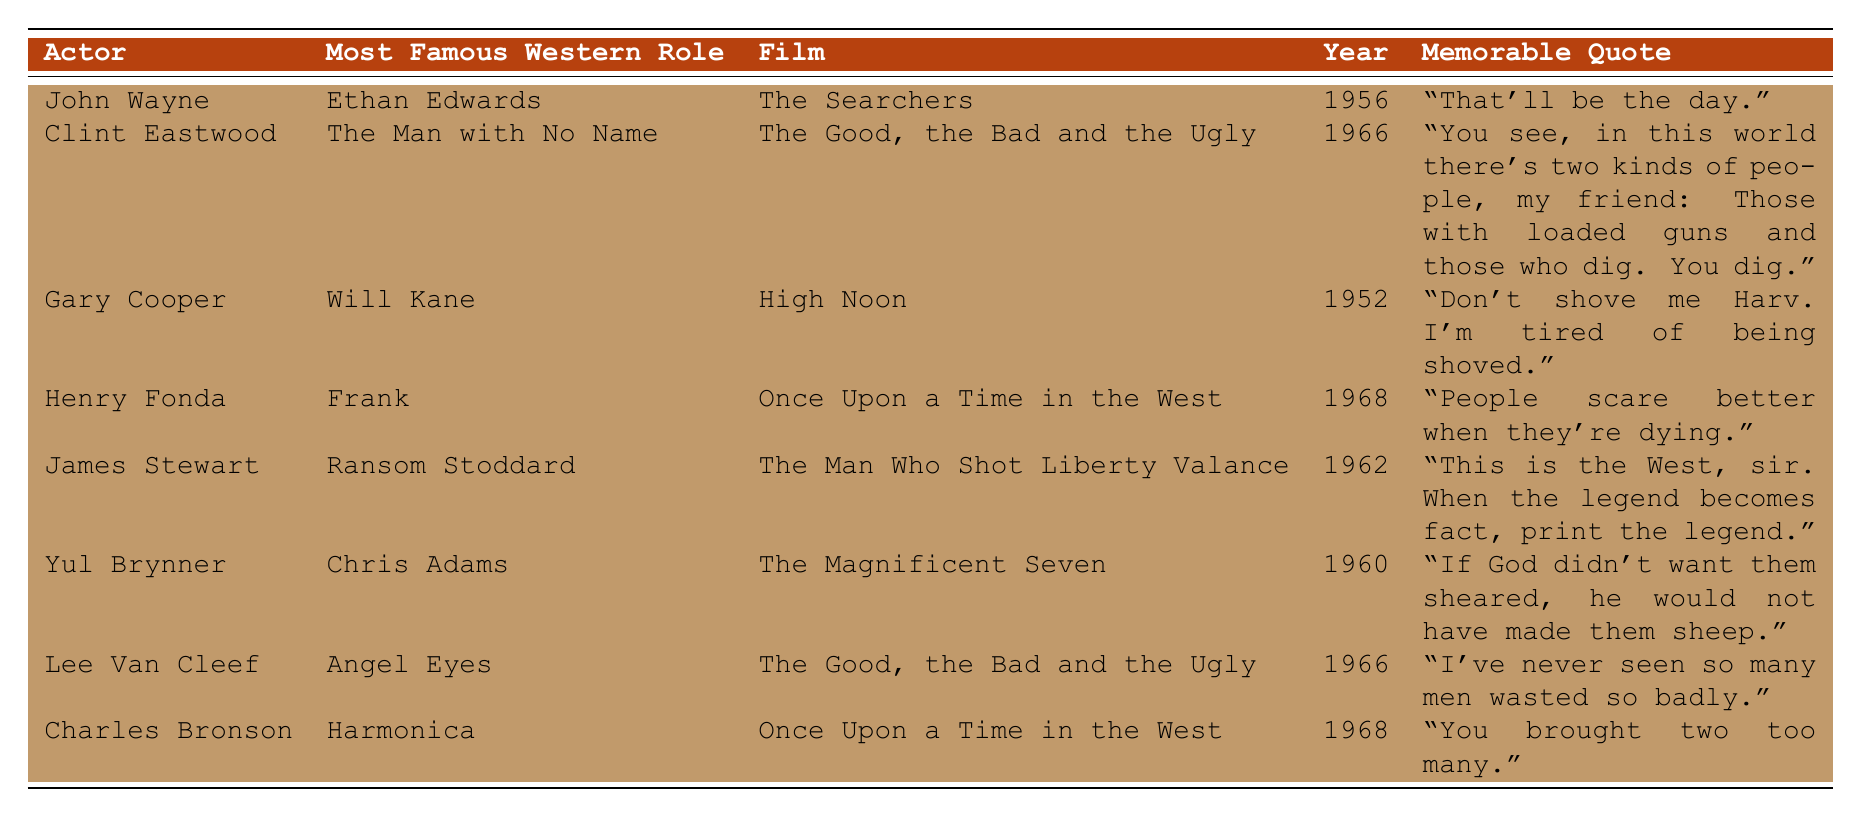What was Clint Eastwood's most famous role in a Western film? The table lists Clint Eastwood's most famous role as "The Man with No Name."
Answer: The Man with No Name In which year was "High Noon" released? The table indicates that "High Noon" was released in the year 1952.
Answer: 1952 Who delivered the quote "This is the West, sir. When the legend becomes fact, print the legend"? According to the table, the quote was delivered by James Stewart.
Answer: James Stewart Which actor played the role of Ethan Edwards? The table states that John Wayne played the role of Ethan Edwards.
Answer: John Wayne Is "The Good, the Bad and the Ugly" the film featuring both Clint Eastwood and Lee Van Cleef? Yes, the table shows that both Clint Eastwood and Lee Van Cleef appeared in "The Good, the Bad and the Ugly."
Answer: Yes What is the difference in years between the release of "Once Upon a Time in the West" and "The Magnificent Seven"? The table shows "Once Upon a Time in the West" was released in 1968 and "The Magnificent Seven" in 1960. The difference is 1968 - 1960 = 8 years.
Answer: 8 years How many different films are represented in the table? There are 8 rows in the table, and the films mentioned are "The Searchers," "The Good, the Bad and the Ugly," "High Noon," "Once Upon a Time in the West," "The Man Who Shot Liberty Valance," and "The Magnificent Seven." The unique films total is 5.
Answer: 5 Which actor from the list delivered the quote, "People scare better when they're dying"? The table attributes this quote to Henry Fonda.
Answer: Henry Fonda What roles in Westerns were played by Gary Cooper and James Stewart? Gary Cooper played Will Kane, and James Stewart played Ransom Stoddard as listed in the table.
Answer: Gary Cooper: Will Kane, James Stewart: Ransom Stoddard Which actor had a role in the Western film released closest to 1960? The films listed closest to 1960 are "The Magnificent Seven" (1960) and "The Good, the Bad and the Ugly" (1966). Yul Brynner played Chris Adams in "The Magnificent Seven," making him the actor associated with the film closest to 1960.
Answer: Yul Brynner 